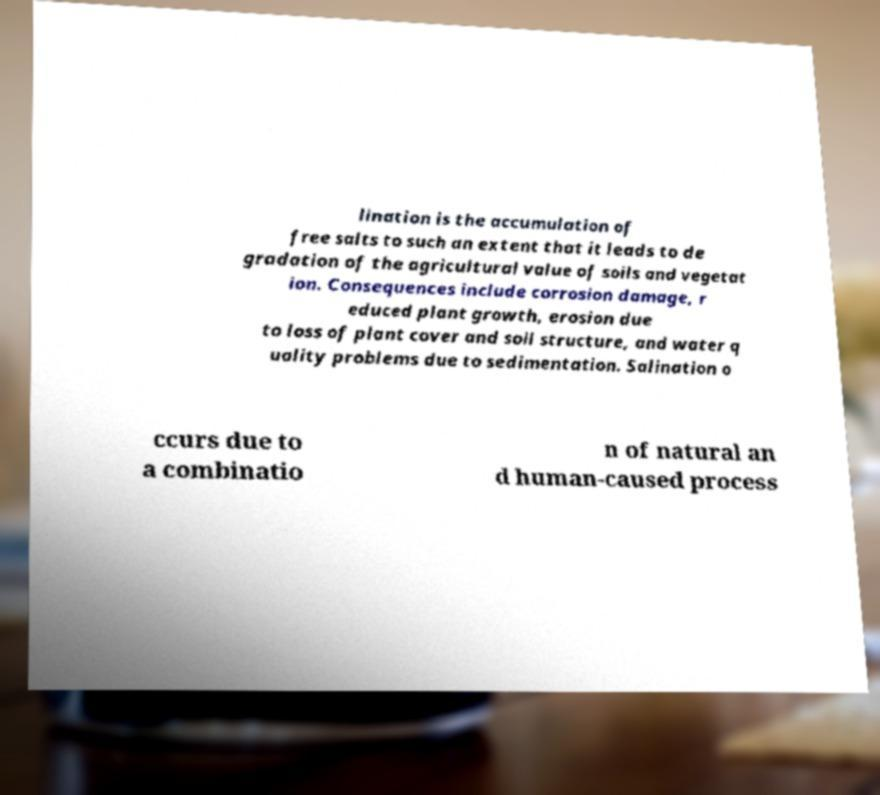Can you read and provide the text displayed in the image?This photo seems to have some interesting text. Can you extract and type it out for me? lination is the accumulation of free salts to such an extent that it leads to de gradation of the agricultural value of soils and vegetat ion. Consequences include corrosion damage, r educed plant growth, erosion due to loss of plant cover and soil structure, and water q uality problems due to sedimentation. Salination o ccurs due to a combinatio n of natural an d human-caused process 